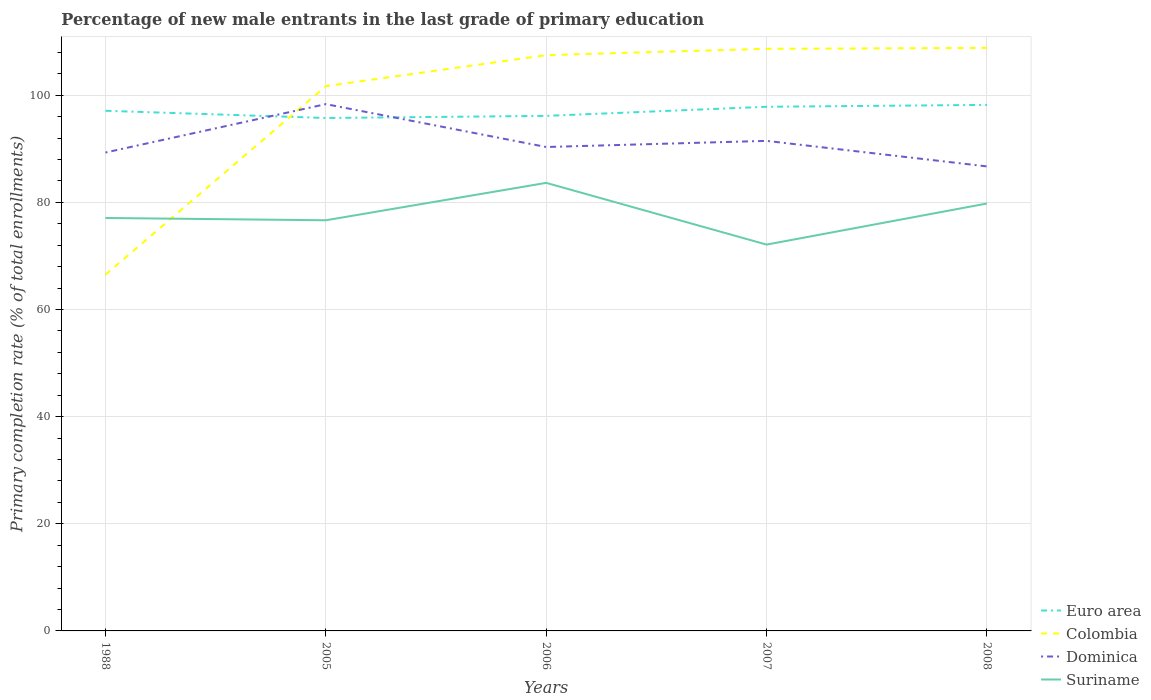Does the line corresponding to Colombia intersect with the line corresponding to Euro area?
Your answer should be compact. Yes. Is the number of lines equal to the number of legend labels?
Ensure brevity in your answer.  Yes. Across all years, what is the maximum percentage of new male entrants in Colombia?
Your answer should be very brief. 66.5. What is the total percentage of new male entrants in Euro area in the graph?
Your response must be concise. -0.4. What is the difference between the highest and the second highest percentage of new male entrants in Suriname?
Provide a succinct answer. 11.52. How many lines are there?
Your answer should be very brief. 4. How many years are there in the graph?
Offer a terse response. 5. What is the difference between two consecutive major ticks on the Y-axis?
Your answer should be very brief. 20. Are the values on the major ticks of Y-axis written in scientific E-notation?
Your answer should be very brief. No. Does the graph contain any zero values?
Your answer should be compact. No. Does the graph contain grids?
Give a very brief answer. Yes. How are the legend labels stacked?
Provide a succinct answer. Vertical. What is the title of the graph?
Offer a very short reply. Percentage of new male entrants in the last grade of primary education. Does "Iceland" appear as one of the legend labels in the graph?
Offer a very short reply. No. What is the label or title of the X-axis?
Your answer should be very brief. Years. What is the label or title of the Y-axis?
Your answer should be very brief. Primary completion rate (% of total enrollments). What is the Primary completion rate (% of total enrollments) of Euro area in 1988?
Keep it short and to the point. 97.09. What is the Primary completion rate (% of total enrollments) in Colombia in 1988?
Provide a succinct answer. 66.5. What is the Primary completion rate (% of total enrollments) of Dominica in 1988?
Ensure brevity in your answer.  89.3. What is the Primary completion rate (% of total enrollments) of Suriname in 1988?
Provide a succinct answer. 77.08. What is the Primary completion rate (% of total enrollments) of Euro area in 2005?
Your response must be concise. 95.74. What is the Primary completion rate (% of total enrollments) of Colombia in 2005?
Ensure brevity in your answer.  101.69. What is the Primary completion rate (% of total enrollments) of Dominica in 2005?
Your response must be concise. 98.33. What is the Primary completion rate (% of total enrollments) in Suriname in 2005?
Offer a very short reply. 76.65. What is the Primary completion rate (% of total enrollments) in Euro area in 2006?
Offer a terse response. 96.14. What is the Primary completion rate (% of total enrollments) of Colombia in 2006?
Keep it short and to the point. 107.48. What is the Primary completion rate (% of total enrollments) of Dominica in 2006?
Keep it short and to the point. 90.33. What is the Primary completion rate (% of total enrollments) in Suriname in 2006?
Your answer should be very brief. 83.63. What is the Primary completion rate (% of total enrollments) in Euro area in 2007?
Provide a short and direct response. 97.84. What is the Primary completion rate (% of total enrollments) in Colombia in 2007?
Your answer should be compact. 108.65. What is the Primary completion rate (% of total enrollments) in Dominica in 2007?
Your answer should be very brief. 91.47. What is the Primary completion rate (% of total enrollments) in Suriname in 2007?
Make the answer very short. 72.11. What is the Primary completion rate (% of total enrollments) of Euro area in 2008?
Ensure brevity in your answer.  98.19. What is the Primary completion rate (% of total enrollments) of Colombia in 2008?
Offer a terse response. 108.82. What is the Primary completion rate (% of total enrollments) of Dominica in 2008?
Give a very brief answer. 86.71. What is the Primary completion rate (% of total enrollments) of Suriname in 2008?
Keep it short and to the point. 79.78. Across all years, what is the maximum Primary completion rate (% of total enrollments) of Euro area?
Your response must be concise. 98.19. Across all years, what is the maximum Primary completion rate (% of total enrollments) of Colombia?
Your answer should be compact. 108.82. Across all years, what is the maximum Primary completion rate (% of total enrollments) of Dominica?
Your answer should be compact. 98.33. Across all years, what is the maximum Primary completion rate (% of total enrollments) in Suriname?
Keep it short and to the point. 83.63. Across all years, what is the minimum Primary completion rate (% of total enrollments) in Euro area?
Provide a succinct answer. 95.74. Across all years, what is the minimum Primary completion rate (% of total enrollments) in Colombia?
Keep it short and to the point. 66.5. Across all years, what is the minimum Primary completion rate (% of total enrollments) in Dominica?
Keep it short and to the point. 86.71. Across all years, what is the minimum Primary completion rate (% of total enrollments) of Suriname?
Your response must be concise. 72.11. What is the total Primary completion rate (% of total enrollments) in Euro area in the graph?
Provide a succinct answer. 484.99. What is the total Primary completion rate (% of total enrollments) of Colombia in the graph?
Offer a terse response. 493.14. What is the total Primary completion rate (% of total enrollments) of Dominica in the graph?
Make the answer very short. 456.13. What is the total Primary completion rate (% of total enrollments) in Suriname in the graph?
Your response must be concise. 389.26. What is the difference between the Primary completion rate (% of total enrollments) in Euro area in 1988 and that in 2005?
Offer a very short reply. 1.35. What is the difference between the Primary completion rate (% of total enrollments) in Colombia in 1988 and that in 2005?
Your answer should be compact. -35.19. What is the difference between the Primary completion rate (% of total enrollments) in Dominica in 1988 and that in 2005?
Your answer should be compact. -9.03. What is the difference between the Primary completion rate (% of total enrollments) in Suriname in 1988 and that in 2005?
Provide a succinct answer. 0.43. What is the difference between the Primary completion rate (% of total enrollments) of Euro area in 1988 and that in 2006?
Offer a terse response. 0.95. What is the difference between the Primary completion rate (% of total enrollments) of Colombia in 1988 and that in 2006?
Offer a terse response. -40.98. What is the difference between the Primary completion rate (% of total enrollments) in Dominica in 1988 and that in 2006?
Your answer should be compact. -1.03. What is the difference between the Primary completion rate (% of total enrollments) of Suriname in 1988 and that in 2006?
Provide a succinct answer. -6.55. What is the difference between the Primary completion rate (% of total enrollments) in Euro area in 1988 and that in 2007?
Your answer should be compact. -0.75. What is the difference between the Primary completion rate (% of total enrollments) of Colombia in 1988 and that in 2007?
Offer a very short reply. -42.15. What is the difference between the Primary completion rate (% of total enrollments) of Dominica in 1988 and that in 2007?
Your response must be concise. -2.17. What is the difference between the Primary completion rate (% of total enrollments) of Suriname in 1988 and that in 2007?
Provide a succinct answer. 4.97. What is the difference between the Primary completion rate (% of total enrollments) in Euro area in 1988 and that in 2008?
Ensure brevity in your answer.  -1.1. What is the difference between the Primary completion rate (% of total enrollments) in Colombia in 1988 and that in 2008?
Offer a very short reply. -42.32. What is the difference between the Primary completion rate (% of total enrollments) of Dominica in 1988 and that in 2008?
Offer a very short reply. 2.59. What is the difference between the Primary completion rate (% of total enrollments) of Suriname in 1988 and that in 2008?
Your response must be concise. -2.7. What is the difference between the Primary completion rate (% of total enrollments) in Euro area in 2005 and that in 2006?
Your answer should be compact. -0.4. What is the difference between the Primary completion rate (% of total enrollments) of Colombia in 2005 and that in 2006?
Offer a terse response. -5.79. What is the difference between the Primary completion rate (% of total enrollments) of Dominica in 2005 and that in 2006?
Keep it short and to the point. 8. What is the difference between the Primary completion rate (% of total enrollments) of Suriname in 2005 and that in 2006?
Your answer should be very brief. -6.98. What is the difference between the Primary completion rate (% of total enrollments) of Euro area in 2005 and that in 2007?
Keep it short and to the point. -2.1. What is the difference between the Primary completion rate (% of total enrollments) in Colombia in 2005 and that in 2007?
Make the answer very short. -6.97. What is the difference between the Primary completion rate (% of total enrollments) in Dominica in 2005 and that in 2007?
Make the answer very short. 6.86. What is the difference between the Primary completion rate (% of total enrollments) of Suriname in 2005 and that in 2007?
Your answer should be compact. 4.54. What is the difference between the Primary completion rate (% of total enrollments) of Euro area in 2005 and that in 2008?
Provide a short and direct response. -2.45. What is the difference between the Primary completion rate (% of total enrollments) of Colombia in 2005 and that in 2008?
Give a very brief answer. -7.14. What is the difference between the Primary completion rate (% of total enrollments) of Dominica in 2005 and that in 2008?
Your answer should be very brief. 11.63. What is the difference between the Primary completion rate (% of total enrollments) in Suriname in 2005 and that in 2008?
Your answer should be very brief. -3.13. What is the difference between the Primary completion rate (% of total enrollments) in Euro area in 2006 and that in 2007?
Offer a very short reply. -1.7. What is the difference between the Primary completion rate (% of total enrollments) of Colombia in 2006 and that in 2007?
Provide a short and direct response. -1.18. What is the difference between the Primary completion rate (% of total enrollments) in Dominica in 2006 and that in 2007?
Offer a very short reply. -1.15. What is the difference between the Primary completion rate (% of total enrollments) of Suriname in 2006 and that in 2007?
Provide a succinct answer. 11.52. What is the difference between the Primary completion rate (% of total enrollments) in Euro area in 2006 and that in 2008?
Offer a terse response. -2.05. What is the difference between the Primary completion rate (% of total enrollments) in Colombia in 2006 and that in 2008?
Your answer should be very brief. -1.35. What is the difference between the Primary completion rate (% of total enrollments) of Dominica in 2006 and that in 2008?
Your answer should be very brief. 3.62. What is the difference between the Primary completion rate (% of total enrollments) in Suriname in 2006 and that in 2008?
Offer a very short reply. 3.85. What is the difference between the Primary completion rate (% of total enrollments) in Euro area in 2007 and that in 2008?
Give a very brief answer. -0.35. What is the difference between the Primary completion rate (% of total enrollments) in Colombia in 2007 and that in 2008?
Provide a short and direct response. -0.17. What is the difference between the Primary completion rate (% of total enrollments) in Dominica in 2007 and that in 2008?
Give a very brief answer. 4.77. What is the difference between the Primary completion rate (% of total enrollments) in Suriname in 2007 and that in 2008?
Offer a terse response. -7.67. What is the difference between the Primary completion rate (% of total enrollments) in Euro area in 1988 and the Primary completion rate (% of total enrollments) in Colombia in 2005?
Provide a short and direct response. -4.6. What is the difference between the Primary completion rate (% of total enrollments) in Euro area in 1988 and the Primary completion rate (% of total enrollments) in Dominica in 2005?
Your answer should be very brief. -1.24. What is the difference between the Primary completion rate (% of total enrollments) of Euro area in 1988 and the Primary completion rate (% of total enrollments) of Suriname in 2005?
Make the answer very short. 20.44. What is the difference between the Primary completion rate (% of total enrollments) of Colombia in 1988 and the Primary completion rate (% of total enrollments) of Dominica in 2005?
Provide a short and direct response. -31.83. What is the difference between the Primary completion rate (% of total enrollments) of Colombia in 1988 and the Primary completion rate (% of total enrollments) of Suriname in 2005?
Ensure brevity in your answer.  -10.15. What is the difference between the Primary completion rate (% of total enrollments) of Dominica in 1988 and the Primary completion rate (% of total enrollments) of Suriname in 2005?
Provide a succinct answer. 12.65. What is the difference between the Primary completion rate (% of total enrollments) of Euro area in 1988 and the Primary completion rate (% of total enrollments) of Colombia in 2006?
Give a very brief answer. -10.39. What is the difference between the Primary completion rate (% of total enrollments) in Euro area in 1988 and the Primary completion rate (% of total enrollments) in Dominica in 2006?
Make the answer very short. 6.76. What is the difference between the Primary completion rate (% of total enrollments) in Euro area in 1988 and the Primary completion rate (% of total enrollments) in Suriname in 2006?
Ensure brevity in your answer.  13.46. What is the difference between the Primary completion rate (% of total enrollments) in Colombia in 1988 and the Primary completion rate (% of total enrollments) in Dominica in 2006?
Offer a terse response. -23.83. What is the difference between the Primary completion rate (% of total enrollments) of Colombia in 1988 and the Primary completion rate (% of total enrollments) of Suriname in 2006?
Give a very brief answer. -17.13. What is the difference between the Primary completion rate (% of total enrollments) in Dominica in 1988 and the Primary completion rate (% of total enrollments) in Suriname in 2006?
Your answer should be compact. 5.66. What is the difference between the Primary completion rate (% of total enrollments) of Euro area in 1988 and the Primary completion rate (% of total enrollments) of Colombia in 2007?
Offer a terse response. -11.56. What is the difference between the Primary completion rate (% of total enrollments) in Euro area in 1988 and the Primary completion rate (% of total enrollments) in Dominica in 2007?
Keep it short and to the point. 5.62. What is the difference between the Primary completion rate (% of total enrollments) of Euro area in 1988 and the Primary completion rate (% of total enrollments) of Suriname in 2007?
Make the answer very short. 24.98. What is the difference between the Primary completion rate (% of total enrollments) of Colombia in 1988 and the Primary completion rate (% of total enrollments) of Dominica in 2007?
Keep it short and to the point. -24.97. What is the difference between the Primary completion rate (% of total enrollments) of Colombia in 1988 and the Primary completion rate (% of total enrollments) of Suriname in 2007?
Make the answer very short. -5.61. What is the difference between the Primary completion rate (% of total enrollments) in Dominica in 1988 and the Primary completion rate (% of total enrollments) in Suriname in 2007?
Offer a very short reply. 17.19. What is the difference between the Primary completion rate (% of total enrollments) of Euro area in 1988 and the Primary completion rate (% of total enrollments) of Colombia in 2008?
Offer a very short reply. -11.73. What is the difference between the Primary completion rate (% of total enrollments) in Euro area in 1988 and the Primary completion rate (% of total enrollments) in Dominica in 2008?
Offer a terse response. 10.38. What is the difference between the Primary completion rate (% of total enrollments) of Euro area in 1988 and the Primary completion rate (% of total enrollments) of Suriname in 2008?
Offer a terse response. 17.3. What is the difference between the Primary completion rate (% of total enrollments) in Colombia in 1988 and the Primary completion rate (% of total enrollments) in Dominica in 2008?
Your response must be concise. -20.21. What is the difference between the Primary completion rate (% of total enrollments) in Colombia in 1988 and the Primary completion rate (% of total enrollments) in Suriname in 2008?
Ensure brevity in your answer.  -13.28. What is the difference between the Primary completion rate (% of total enrollments) in Dominica in 1988 and the Primary completion rate (% of total enrollments) in Suriname in 2008?
Offer a very short reply. 9.51. What is the difference between the Primary completion rate (% of total enrollments) in Euro area in 2005 and the Primary completion rate (% of total enrollments) in Colombia in 2006?
Make the answer very short. -11.73. What is the difference between the Primary completion rate (% of total enrollments) in Euro area in 2005 and the Primary completion rate (% of total enrollments) in Dominica in 2006?
Offer a terse response. 5.41. What is the difference between the Primary completion rate (% of total enrollments) of Euro area in 2005 and the Primary completion rate (% of total enrollments) of Suriname in 2006?
Give a very brief answer. 12.11. What is the difference between the Primary completion rate (% of total enrollments) of Colombia in 2005 and the Primary completion rate (% of total enrollments) of Dominica in 2006?
Your answer should be compact. 11.36. What is the difference between the Primary completion rate (% of total enrollments) of Colombia in 2005 and the Primary completion rate (% of total enrollments) of Suriname in 2006?
Offer a very short reply. 18.05. What is the difference between the Primary completion rate (% of total enrollments) in Dominica in 2005 and the Primary completion rate (% of total enrollments) in Suriname in 2006?
Provide a short and direct response. 14.7. What is the difference between the Primary completion rate (% of total enrollments) of Euro area in 2005 and the Primary completion rate (% of total enrollments) of Colombia in 2007?
Your answer should be compact. -12.91. What is the difference between the Primary completion rate (% of total enrollments) in Euro area in 2005 and the Primary completion rate (% of total enrollments) in Dominica in 2007?
Keep it short and to the point. 4.27. What is the difference between the Primary completion rate (% of total enrollments) in Euro area in 2005 and the Primary completion rate (% of total enrollments) in Suriname in 2007?
Ensure brevity in your answer.  23.63. What is the difference between the Primary completion rate (% of total enrollments) of Colombia in 2005 and the Primary completion rate (% of total enrollments) of Dominica in 2007?
Offer a terse response. 10.21. What is the difference between the Primary completion rate (% of total enrollments) in Colombia in 2005 and the Primary completion rate (% of total enrollments) in Suriname in 2007?
Provide a short and direct response. 29.58. What is the difference between the Primary completion rate (% of total enrollments) of Dominica in 2005 and the Primary completion rate (% of total enrollments) of Suriname in 2007?
Make the answer very short. 26.22. What is the difference between the Primary completion rate (% of total enrollments) of Euro area in 2005 and the Primary completion rate (% of total enrollments) of Colombia in 2008?
Your answer should be very brief. -13.08. What is the difference between the Primary completion rate (% of total enrollments) of Euro area in 2005 and the Primary completion rate (% of total enrollments) of Dominica in 2008?
Your answer should be compact. 9.04. What is the difference between the Primary completion rate (% of total enrollments) in Euro area in 2005 and the Primary completion rate (% of total enrollments) in Suriname in 2008?
Make the answer very short. 15.96. What is the difference between the Primary completion rate (% of total enrollments) in Colombia in 2005 and the Primary completion rate (% of total enrollments) in Dominica in 2008?
Your answer should be very brief. 14.98. What is the difference between the Primary completion rate (% of total enrollments) in Colombia in 2005 and the Primary completion rate (% of total enrollments) in Suriname in 2008?
Your answer should be very brief. 21.9. What is the difference between the Primary completion rate (% of total enrollments) of Dominica in 2005 and the Primary completion rate (% of total enrollments) of Suriname in 2008?
Give a very brief answer. 18.55. What is the difference between the Primary completion rate (% of total enrollments) in Euro area in 2006 and the Primary completion rate (% of total enrollments) in Colombia in 2007?
Keep it short and to the point. -12.52. What is the difference between the Primary completion rate (% of total enrollments) of Euro area in 2006 and the Primary completion rate (% of total enrollments) of Dominica in 2007?
Ensure brevity in your answer.  4.66. What is the difference between the Primary completion rate (% of total enrollments) in Euro area in 2006 and the Primary completion rate (% of total enrollments) in Suriname in 2007?
Keep it short and to the point. 24.03. What is the difference between the Primary completion rate (% of total enrollments) of Colombia in 2006 and the Primary completion rate (% of total enrollments) of Dominica in 2007?
Provide a succinct answer. 16. What is the difference between the Primary completion rate (% of total enrollments) of Colombia in 2006 and the Primary completion rate (% of total enrollments) of Suriname in 2007?
Your response must be concise. 35.37. What is the difference between the Primary completion rate (% of total enrollments) in Dominica in 2006 and the Primary completion rate (% of total enrollments) in Suriname in 2007?
Ensure brevity in your answer.  18.22. What is the difference between the Primary completion rate (% of total enrollments) of Euro area in 2006 and the Primary completion rate (% of total enrollments) of Colombia in 2008?
Your answer should be compact. -12.69. What is the difference between the Primary completion rate (% of total enrollments) in Euro area in 2006 and the Primary completion rate (% of total enrollments) in Dominica in 2008?
Your response must be concise. 9.43. What is the difference between the Primary completion rate (% of total enrollments) of Euro area in 2006 and the Primary completion rate (% of total enrollments) of Suriname in 2008?
Your answer should be very brief. 16.35. What is the difference between the Primary completion rate (% of total enrollments) of Colombia in 2006 and the Primary completion rate (% of total enrollments) of Dominica in 2008?
Offer a terse response. 20.77. What is the difference between the Primary completion rate (% of total enrollments) of Colombia in 2006 and the Primary completion rate (% of total enrollments) of Suriname in 2008?
Give a very brief answer. 27.69. What is the difference between the Primary completion rate (% of total enrollments) of Dominica in 2006 and the Primary completion rate (% of total enrollments) of Suriname in 2008?
Offer a very short reply. 10.54. What is the difference between the Primary completion rate (% of total enrollments) in Euro area in 2007 and the Primary completion rate (% of total enrollments) in Colombia in 2008?
Your answer should be very brief. -10.99. What is the difference between the Primary completion rate (% of total enrollments) of Euro area in 2007 and the Primary completion rate (% of total enrollments) of Dominica in 2008?
Make the answer very short. 11.13. What is the difference between the Primary completion rate (% of total enrollments) in Euro area in 2007 and the Primary completion rate (% of total enrollments) in Suriname in 2008?
Provide a short and direct response. 18.05. What is the difference between the Primary completion rate (% of total enrollments) of Colombia in 2007 and the Primary completion rate (% of total enrollments) of Dominica in 2008?
Provide a succinct answer. 21.95. What is the difference between the Primary completion rate (% of total enrollments) in Colombia in 2007 and the Primary completion rate (% of total enrollments) in Suriname in 2008?
Offer a very short reply. 28.87. What is the difference between the Primary completion rate (% of total enrollments) in Dominica in 2007 and the Primary completion rate (% of total enrollments) in Suriname in 2008?
Offer a very short reply. 11.69. What is the average Primary completion rate (% of total enrollments) in Euro area per year?
Ensure brevity in your answer.  97. What is the average Primary completion rate (% of total enrollments) of Colombia per year?
Offer a very short reply. 98.63. What is the average Primary completion rate (% of total enrollments) of Dominica per year?
Offer a terse response. 91.23. What is the average Primary completion rate (% of total enrollments) in Suriname per year?
Your answer should be compact. 77.85. In the year 1988, what is the difference between the Primary completion rate (% of total enrollments) in Euro area and Primary completion rate (% of total enrollments) in Colombia?
Keep it short and to the point. 30.59. In the year 1988, what is the difference between the Primary completion rate (% of total enrollments) of Euro area and Primary completion rate (% of total enrollments) of Dominica?
Offer a very short reply. 7.79. In the year 1988, what is the difference between the Primary completion rate (% of total enrollments) in Euro area and Primary completion rate (% of total enrollments) in Suriname?
Provide a short and direct response. 20.01. In the year 1988, what is the difference between the Primary completion rate (% of total enrollments) in Colombia and Primary completion rate (% of total enrollments) in Dominica?
Provide a succinct answer. -22.8. In the year 1988, what is the difference between the Primary completion rate (% of total enrollments) in Colombia and Primary completion rate (% of total enrollments) in Suriname?
Make the answer very short. -10.58. In the year 1988, what is the difference between the Primary completion rate (% of total enrollments) of Dominica and Primary completion rate (% of total enrollments) of Suriname?
Offer a very short reply. 12.22. In the year 2005, what is the difference between the Primary completion rate (% of total enrollments) of Euro area and Primary completion rate (% of total enrollments) of Colombia?
Ensure brevity in your answer.  -5.94. In the year 2005, what is the difference between the Primary completion rate (% of total enrollments) in Euro area and Primary completion rate (% of total enrollments) in Dominica?
Offer a very short reply. -2.59. In the year 2005, what is the difference between the Primary completion rate (% of total enrollments) of Euro area and Primary completion rate (% of total enrollments) of Suriname?
Your response must be concise. 19.09. In the year 2005, what is the difference between the Primary completion rate (% of total enrollments) in Colombia and Primary completion rate (% of total enrollments) in Dominica?
Offer a terse response. 3.35. In the year 2005, what is the difference between the Primary completion rate (% of total enrollments) in Colombia and Primary completion rate (% of total enrollments) in Suriname?
Your answer should be compact. 25.03. In the year 2005, what is the difference between the Primary completion rate (% of total enrollments) of Dominica and Primary completion rate (% of total enrollments) of Suriname?
Your response must be concise. 21.68. In the year 2006, what is the difference between the Primary completion rate (% of total enrollments) in Euro area and Primary completion rate (% of total enrollments) in Colombia?
Provide a short and direct response. -11.34. In the year 2006, what is the difference between the Primary completion rate (% of total enrollments) of Euro area and Primary completion rate (% of total enrollments) of Dominica?
Keep it short and to the point. 5.81. In the year 2006, what is the difference between the Primary completion rate (% of total enrollments) in Euro area and Primary completion rate (% of total enrollments) in Suriname?
Your answer should be very brief. 12.5. In the year 2006, what is the difference between the Primary completion rate (% of total enrollments) of Colombia and Primary completion rate (% of total enrollments) of Dominica?
Offer a very short reply. 17.15. In the year 2006, what is the difference between the Primary completion rate (% of total enrollments) in Colombia and Primary completion rate (% of total enrollments) in Suriname?
Your answer should be compact. 23.84. In the year 2006, what is the difference between the Primary completion rate (% of total enrollments) of Dominica and Primary completion rate (% of total enrollments) of Suriname?
Your answer should be compact. 6.69. In the year 2007, what is the difference between the Primary completion rate (% of total enrollments) in Euro area and Primary completion rate (% of total enrollments) in Colombia?
Make the answer very short. -10.82. In the year 2007, what is the difference between the Primary completion rate (% of total enrollments) in Euro area and Primary completion rate (% of total enrollments) in Dominica?
Provide a short and direct response. 6.37. In the year 2007, what is the difference between the Primary completion rate (% of total enrollments) in Euro area and Primary completion rate (% of total enrollments) in Suriname?
Provide a short and direct response. 25.73. In the year 2007, what is the difference between the Primary completion rate (% of total enrollments) in Colombia and Primary completion rate (% of total enrollments) in Dominica?
Your response must be concise. 17.18. In the year 2007, what is the difference between the Primary completion rate (% of total enrollments) in Colombia and Primary completion rate (% of total enrollments) in Suriname?
Give a very brief answer. 36.54. In the year 2007, what is the difference between the Primary completion rate (% of total enrollments) in Dominica and Primary completion rate (% of total enrollments) in Suriname?
Provide a succinct answer. 19.36. In the year 2008, what is the difference between the Primary completion rate (% of total enrollments) of Euro area and Primary completion rate (% of total enrollments) of Colombia?
Your response must be concise. -10.64. In the year 2008, what is the difference between the Primary completion rate (% of total enrollments) in Euro area and Primary completion rate (% of total enrollments) in Dominica?
Make the answer very short. 11.48. In the year 2008, what is the difference between the Primary completion rate (% of total enrollments) in Euro area and Primary completion rate (% of total enrollments) in Suriname?
Provide a succinct answer. 18.4. In the year 2008, what is the difference between the Primary completion rate (% of total enrollments) in Colombia and Primary completion rate (% of total enrollments) in Dominica?
Make the answer very short. 22.12. In the year 2008, what is the difference between the Primary completion rate (% of total enrollments) in Colombia and Primary completion rate (% of total enrollments) in Suriname?
Your response must be concise. 29.04. In the year 2008, what is the difference between the Primary completion rate (% of total enrollments) of Dominica and Primary completion rate (% of total enrollments) of Suriname?
Your answer should be compact. 6.92. What is the ratio of the Primary completion rate (% of total enrollments) in Euro area in 1988 to that in 2005?
Ensure brevity in your answer.  1.01. What is the ratio of the Primary completion rate (% of total enrollments) of Colombia in 1988 to that in 2005?
Ensure brevity in your answer.  0.65. What is the ratio of the Primary completion rate (% of total enrollments) of Dominica in 1988 to that in 2005?
Keep it short and to the point. 0.91. What is the ratio of the Primary completion rate (% of total enrollments) of Suriname in 1988 to that in 2005?
Ensure brevity in your answer.  1.01. What is the ratio of the Primary completion rate (% of total enrollments) of Euro area in 1988 to that in 2006?
Keep it short and to the point. 1.01. What is the ratio of the Primary completion rate (% of total enrollments) of Colombia in 1988 to that in 2006?
Provide a short and direct response. 0.62. What is the ratio of the Primary completion rate (% of total enrollments) in Suriname in 1988 to that in 2006?
Provide a succinct answer. 0.92. What is the ratio of the Primary completion rate (% of total enrollments) of Colombia in 1988 to that in 2007?
Ensure brevity in your answer.  0.61. What is the ratio of the Primary completion rate (% of total enrollments) in Dominica in 1988 to that in 2007?
Your response must be concise. 0.98. What is the ratio of the Primary completion rate (% of total enrollments) in Suriname in 1988 to that in 2007?
Ensure brevity in your answer.  1.07. What is the ratio of the Primary completion rate (% of total enrollments) of Colombia in 1988 to that in 2008?
Your answer should be compact. 0.61. What is the ratio of the Primary completion rate (% of total enrollments) in Dominica in 1988 to that in 2008?
Provide a succinct answer. 1.03. What is the ratio of the Primary completion rate (% of total enrollments) in Suriname in 1988 to that in 2008?
Provide a short and direct response. 0.97. What is the ratio of the Primary completion rate (% of total enrollments) of Colombia in 2005 to that in 2006?
Your answer should be compact. 0.95. What is the ratio of the Primary completion rate (% of total enrollments) of Dominica in 2005 to that in 2006?
Provide a short and direct response. 1.09. What is the ratio of the Primary completion rate (% of total enrollments) of Suriname in 2005 to that in 2006?
Your response must be concise. 0.92. What is the ratio of the Primary completion rate (% of total enrollments) in Euro area in 2005 to that in 2007?
Your response must be concise. 0.98. What is the ratio of the Primary completion rate (% of total enrollments) in Colombia in 2005 to that in 2007?
Your answer should be compact. 0.94. What is the ratio of the Primary completion rate (% of total enrollments) in Dominica in 2005 to that in 2007?
Provide a succinct answer. 1.07. What is the ratio of the Primary completion rate (% of total enrollments) in Suriname in 2005 to that in 2007?
Provide a short and direct response. 1.06. What is the ratio of the Primary completion rate (% of total enrollments) of Euro area in 2005 to that in 2008?
Keep it short and to the point. 0.98. What is the ratio of the Primary completion rate (% of total enrollments) in Colombia in 2005 to that in 2008?
Ensure brevity in your answer.  0.93. What is the ratio of the Primary completion rate (% of total enrollments) of Dominica in 2005 to that in 2008?
Give a very brief answer. 1.13. What is the ratio of the Primary completion rate (% of total enrollments) of Suriname in 2005 to that in 2008?
Your answer should be very brief. 0.96. What is the ratio of the Primary completion rate (% of total enrollments) of Euro area in 2006 to that in 2007?
Your response must be concise. 0.98. What is the ratio of the Primary completion rate (% of total enrollments) in Dominica in 2006 to that in 2007?
Your answer should be compact. 0.99. What is the ratio of the Primary completion rate (% of total enrollments) of Suriname in 2006 to that in 2007?
Keep it short and to the point. 1.16. What is the ratio of the Primary completion rate (% of total enrollments) of Euro area in 2006 to that in 2008?
Ensure brevity in your answer.  0.98. What is the ratio of the Primary completion rate (% of total enrollments) of Colombia in 2006 to that in 2008?
Ensure brevity in your answer.  0.99. What is the ratio of the Primary completion rate (% of total enrollments) in Dominica in 2006 to that in 2008?
Provide a succinct answer. 1.04. What is the ratio of the Primary completion rate (% of total enrollments) of Suriname in 2006 to that in 2008?
Keep it short and to the point. 1.05. What is the ratio of the Primary completion rate (% of total enrollments) of Colombia in 2007 to that in 2008?
Keep it short and to the point. 1. What is the ratio of the Primary completion rate (% of total enrollments) in Dominica in 2007 to that in 2008?
Keep it short and to the point. 1.05. What is the ratio of the Primary completion rate (% of total enrollments) of Suriname in 2007 to that in 2008?
Provide a short and direct response. 0.9. What is the difference between the highest and the second highest Primary completion rate (% of total enrollments) of Euro area?
Provide a succinct answer. 0.35. What is the difference between the highest and the second highest Primary completion rate (% of total enrollments) of Colombia?
Your answer should be compact. 0.17. What is the difference between the highest and the second highest Primary completion rate (% of total enrollments) of Dominica?
Keep it short and to the point. 6.86. What is the difference between the highest and the second highest Primary completion rate (% of total enrollments) of Suriname?
Your response must be concise. 3.85. What is the difference between the highest and the lowest Primary completion rate (% of total enrollments) in Euro area?
Make the answer very short. 2.45. What is the difference between the highest and the lowest Primary completion rate (% of total enrollments) in Colombia?
Make the answer very short. 42.32. What is the difference between the highest and the lowest Primary completion rate (% of total enrollments) in Dominica?
Ensure brevity in your answer.  11.63. What is the difference between the highest and the lowest Primary completion rate (% of total enrollments) in Suriname?
Provide a short and direct response. 11.52. 